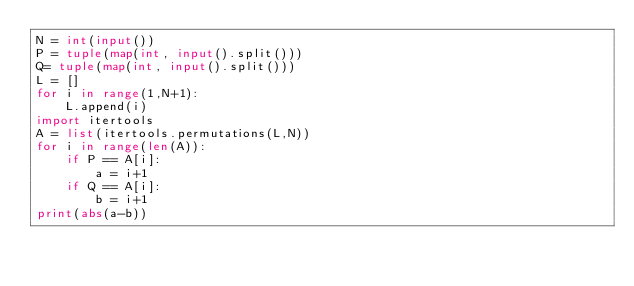Convert code to text. <code><loc_0><loc_0><loc_500><loc_500><_Python_>N = int(input())
P = tuple(map(int, input().split()))
Q= tuple(map(int, input().split()))
L = []
for i in range(1,N+1):
    L.append(i)
import itertools
A = list(itertools.permutations(L,N))
for i in range(len(A)):
    if P == A[i]:
        a = i+1
    if Q == A[i]:
        b = i+1
print(abs(a-b))</code> 